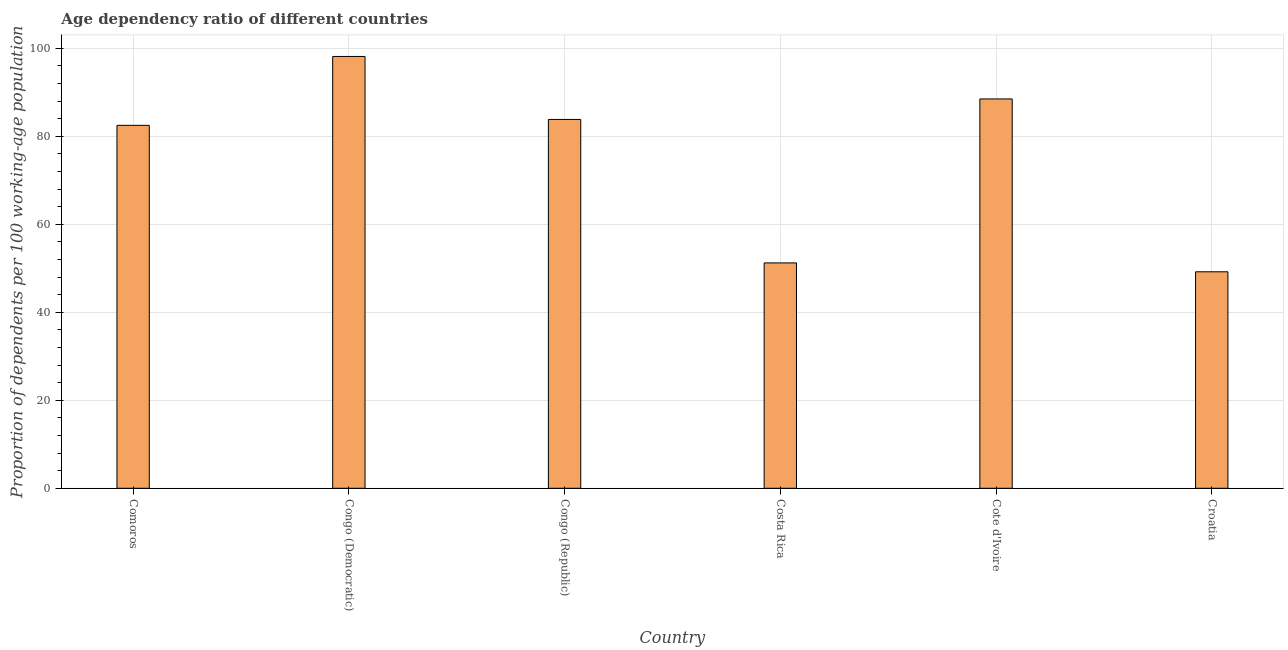Does the graph contain any zero values?
Offer a very short reply. No. What is the title of the graph?
Ensure brevity in your answer.  Age dependency ratio of different countries. What is the label or title of the X-axis?
Your answer should be compact. Country. What is the label or title of the Y-axis?
Offer a terse response. Proportion of dependents per 100 working-age population. What is the age dependency ratio in Croatia?
Give a very brief answer. 49.21. Across all countries, what is the maximum age dependency ratio?
Your response must be concise. 98.15. Across all countries, what is the minimum age dependency ratio?
Provide a succinct answer. 49.21. In which country was the age dependency ratio maximum?
Give a very brief answer. Congo (Democratic). In which country was the age dependency ratio minimum?
Your response must be concise. Croatia. What is the sum of the age dependency ratio?
Your answer should be very brief. 453.4. What is the difference between the age dependency ratio in Cote d'Ivoire and Croatia?
Your answer should be compact. 39.29. What is the average age dependency ratio per country?
Your response must be concise. 75.57. What is the median age dependency ratio?
Offer a very short reply. 83.16. In how many countries, is the age dependency ratio greater than 36 ?
Your response must be concise. 6. What is the ratio of the age dependency ratio in Congo (Republic) to that in Croatia?
Provide a succinct answer. 1.7. What is the difference between the highest and the second highest age dependency ratio?
Make the answer very short. 9.65. Is the sum of the age dependency ratio in Comoros and Costa Rica greater than the maximum age dependency ratio across all countries?
Offer a very short reply. Yes. What is the difference between the highest and the lowest age dependency ratio?
Provide a succinct answer. 48.94. In how many countries, is the age dependency ratio greater than the average age dependency ratio taken over all countries?
Your answer should be very brief. 4. What is the difference between two consecutive major ticks on the Y-axis?
Provide a succinct answer. 20. Are the values on the major ticks of Y-axis written in scientific E-notation?
Ensure brevity in your answer.  No. What is the Proportion of dependents per 100 working-age population in Comoros?
Your answer should be very brief. 82.49. What is the Proportion of dependents per 100 working-age population in Congo (Democratic)?
Ensure brevity in your answer.  98.15. What is the Proportion of dependents per 100 working-age population of Congo (Republic)?
Provide a short and direct response. 83.83. What is the Proportion of dependents per 100 working-age population in Costa Rica?
Your answer should be compact. 51.23. What is the Proportion of dependents per 100 working-age population of Cote d'Ivoire?
Offer a very short reply. 88.5. What is the Proportion of dependents per 100 working-age population in Croatia?
Your response must be concise. 49.21. What is the difference between the Proportion of dependents per 100 working-age population in Comoros and Congo (Democratic)?
Provide a short and direct response. -15.66. What is the difference between the Proportion of dependents per 100 working-age population in Comoros and Congo (Republic)?
Provide a succinct answer. -1.34. What is the difference between the Proportion of dependents per 100 working-age population in Comoros and Costa Rica?
Provide a succinct answer. 31.27. What is the difference between the Proportion of dependents per 100 working-age population in Comoros and Cote d'Ivoire?
Offer a terse response. -6. What is the difference between the Proportion of dependents per 100 working-age population in Comoros and Croatia?
Ensure brevity in your answer.  33.29. What is the difference between the Proportion of dependents per 100 working-age population in Congo (Democratic) and Congo (Republic)?
Ensure brevity in your answer.  14.32. What is the difference between the Proportion of dependents per 100 working-age population in Congo (Democratic) and Costa Rica?
Ensure brevity in your answer.  46.92. What is the difference between the Proportion of dependents per 100 working-age population in Congo (Democratic) and Cote d'Ivoire?
Offer a terse response. 9.65. What is the difference between the Proportion of dependents per 100 working-age population in Congo (Democratic) and Croatia?
Provide a succinct answer. 48.94. What is the difference between the Proportion of dependents per 100 working-age population in Congo (Republic) and Costa Rica?
Offer a very short reply. 32.61. What is the difference between the Proportion of dependents per 100 working-age population in Congo (Republic) and Cote d'Ivoire?
Offer a terse response. -4.66. What is the difference between the Proportion of dependents per 100 working-age population in Congo (Republic) and Croatia?
Your answer should be very brief. 34.63. What is the difference between the Proportion of dependents per 100 working-age population in Costa Rica and Cote d'Ivoire?
Your response must be concise. -37.27. What is the difference between the Proportion of dependents per 100 working-age population in Costa Rica and Croatia?
Provide a short and direct response. 2.02. What is the difference between the Proportion of dependents per 100 working-age population in Cote d'Ivoire and Croatia?
Your answer should be very brief. 39.29. What is the ratio of the Proportion of dependents per 100 working-age population in Comoros to that in Congo (Democratic)?
Your response must be concise. 0.84. What is the ratio of the Proportion of dependents per 100 working-age population in Comoros to that in Costa Rica?
Provide a short and direct response. 1.61. What is the ratio of the Proportion of dependents per 100 working-age population in Comoros to that in Cote d'Ivoire?
Offer a very short reply. 0.93. What is the ratio of the Proportion of dependents per 100 working-age population in Comoros to that in Croatia?
Offer a very short reply. 1.68. What is the ratio of the Proportion of dependents per 100 working-age population in Congo (Democratic) to that in Congo (Republic)?
Provide a short and direct response. 1.17. What is the ratio of the Proportion of dependents per 100 working-age population in Congo (Democratic) to that in Costa Rica?
Make the answer very short. 1.92. What is the ratio of the Proportion of dependents per 100 working-age population in Congo (Democratic) to that in Cote d'Ivoire?
Give a very brief answer. 1.11. What is the ratio of the Proportion of dependents per 100 working-age population in Congo (Democratic) to that in Croatia?
Your answer should be compact. 2. What is the ratio of the Proportion of dependents per 100 working-age population in Congo (Republic) to that in Costa Rica?
Your answer should be very brief. 1.64. What is the ratio of the Proportion of dependents per 100 working-age population in Congo (Republic) to that in Cote d'Ivoire?
Provide a short and direct response. 0.95. What is the ratio of the Proportion of dependents per 100 working-age population in Congo (Republic) to that in Croatia?
Provide a succinct answer. 1.7. What is the ratio of the Proportion of dependents per 100 working-age population in Costa Rica to that in Cote d'Ivoire?
Keep it short and to the point. 0.58. What is the ratio of the Proportion of dependents per 100 working-age population in Costa Rica to that in Croatia?
Your response must be concise. 1.04. What is the ratio of the Proportion of dependents per 100 working-age population in Cote d'Ivoire to that in Croatia?
Your answer should be very brief. 1.8. 